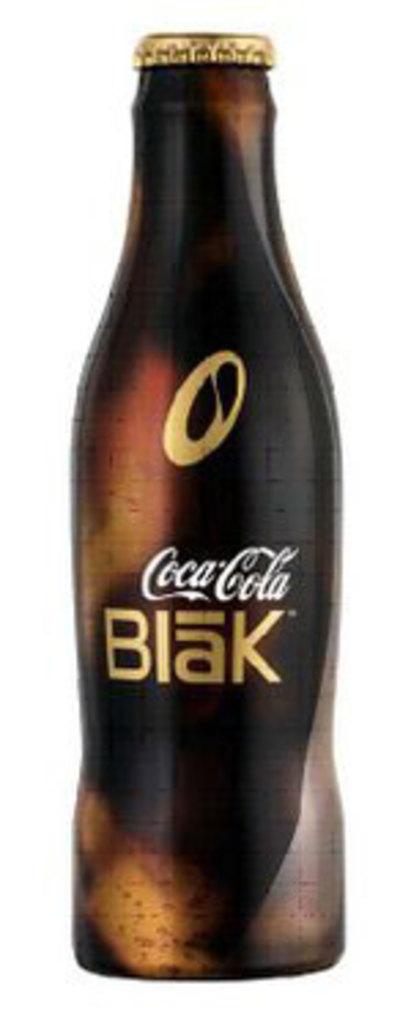What brand's product is this?
Offer a very short reply. Coca cola. 